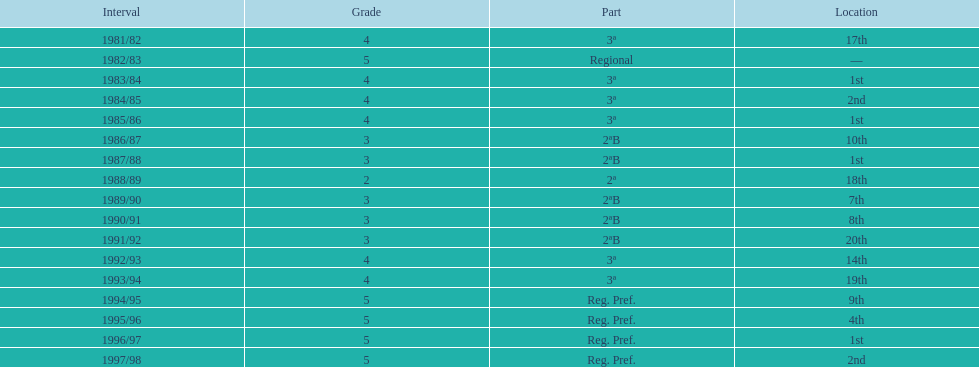Can you parse all the data within this table? {'header': ['Interval', 'Grade', 'Part', 'Location'], 'rows': [['1981/82', '4', '3ª', '17th'], ['1982/83', '5', 'Regional', '—'], ['1983/84', '4', '3ª', '1st'], ['1984/85', '4', '3ª', '2nd'], ['1985/86', '4', '3ª', '1st'], ['1986/87', '3', '2ªB', '10th'], ['1987/88', '3', '2ªB', '1st'], ['1988/89', '2', '2ª', '18th'], ['1989/90', '3', '2ªB', '7th'], ['1990/91', '3', '2ªB', '8th'], ['1991/92', '3', '2ªB', '20th'], ['1992/93', '4', '3ª', '14th'], ['1993/94', '4', '3ª', '19th'], ['1994/95', '5', 'Reg. Pref.', '9th'], ['1995/96', '5', 'Reg. Pref.', '4th'], ['1996/97', '5', 'Reg. Pref.', '1st'], ['1997/98', '5', 'Reg. Pref.', '2nd']]} What was the duration of their stay in tier 3 in years? 5. 